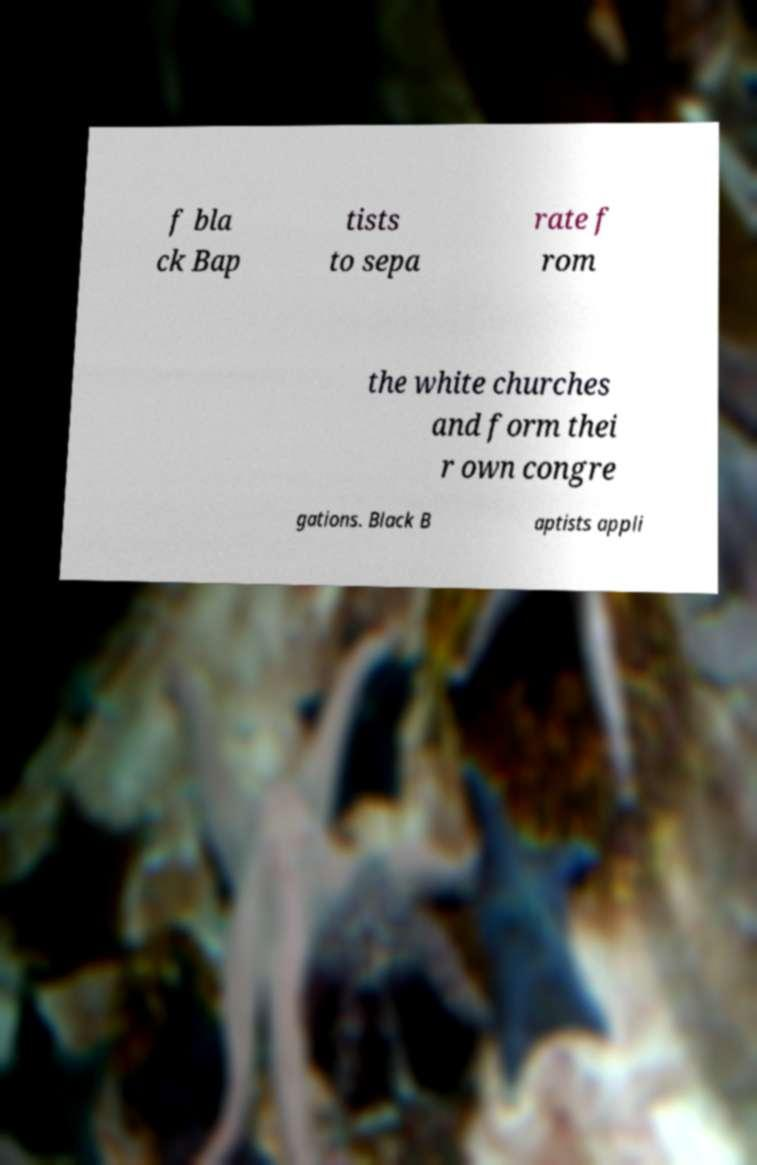Please identify and transcribe the text found in this image. f bla ck Bap tists to sepa rate f rom the white churches and form thei r own congre gations. Black B aptists appli 